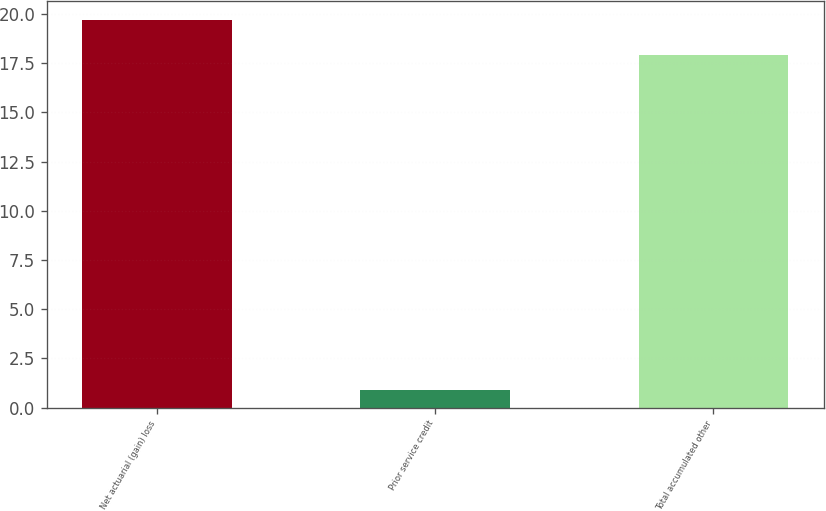Convert chart to OTSL. <chart><loc_0><loc_0><loc_500><loc_500><bar_chart><fcel>Net actuarial (gain) loss<fcel>Prior service credit<fcel>Total accumulated other<nl><fcel>19.69<fcel>0.9<fcel>17.9<nl></chart> 